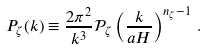<formula> <loc_0><loc_0><loc_500><loc_500>P _ { \zeta } ( k ) \equiv \frac { 2 \pi ^ { 2 } } { k ^ { 3 } } \mathcal { P } _ { \zeta } \left ( \frac { k } { a H } \right ) ^ { n _ { \zeta } - 1 } \, .</formula> 